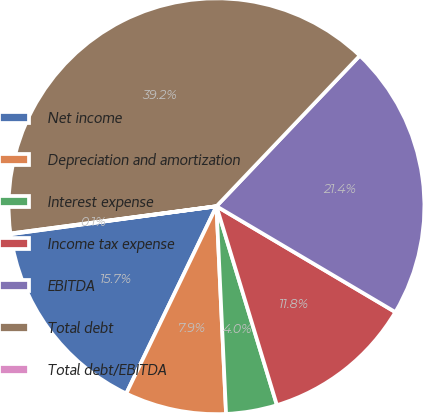Convert chart. <chart><loc_0><loc_0><loc_500><loc_500><pie_chart><fcel>Net income<fcel>Depreciation and amortization<fcel>Interest expense<fcel>Income tax expense<fcel>EBITDA<fcel>Total debt<fcel>Total debt/EBITDA<nl><fcel>15.71%<fcel>7.88%<fcel>3.96%<fcel>11.8%<fcel>21.4%<fcel>39.2%<fcel>0.05%<nl></chart> 